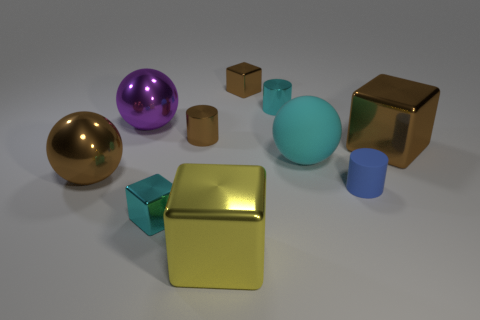Subtract all large brown spheres. How many spheres are left? 2 Subtract all purple spheres. How many spheres are left? 2 Subtract all blocks. How many objects are left? 6 Subtract all brown balls. How many cyan cylinders are left? 1 Subtract all spheres. Subtract all small gray matte spheres. How many objects are left? 7 Add 4 yellow blocks. How many yellow blocks are left? 5 Add 4 big gray rubber balls. How many big gray rubber balls exist? 4 Subtract 0 red cylinders. How many objects are left? 10 Subtract 2 cubes. How many cubes are left? 2 Subtract all red blocks. Subtract all blue cylinders. How many blocks are left? 4 